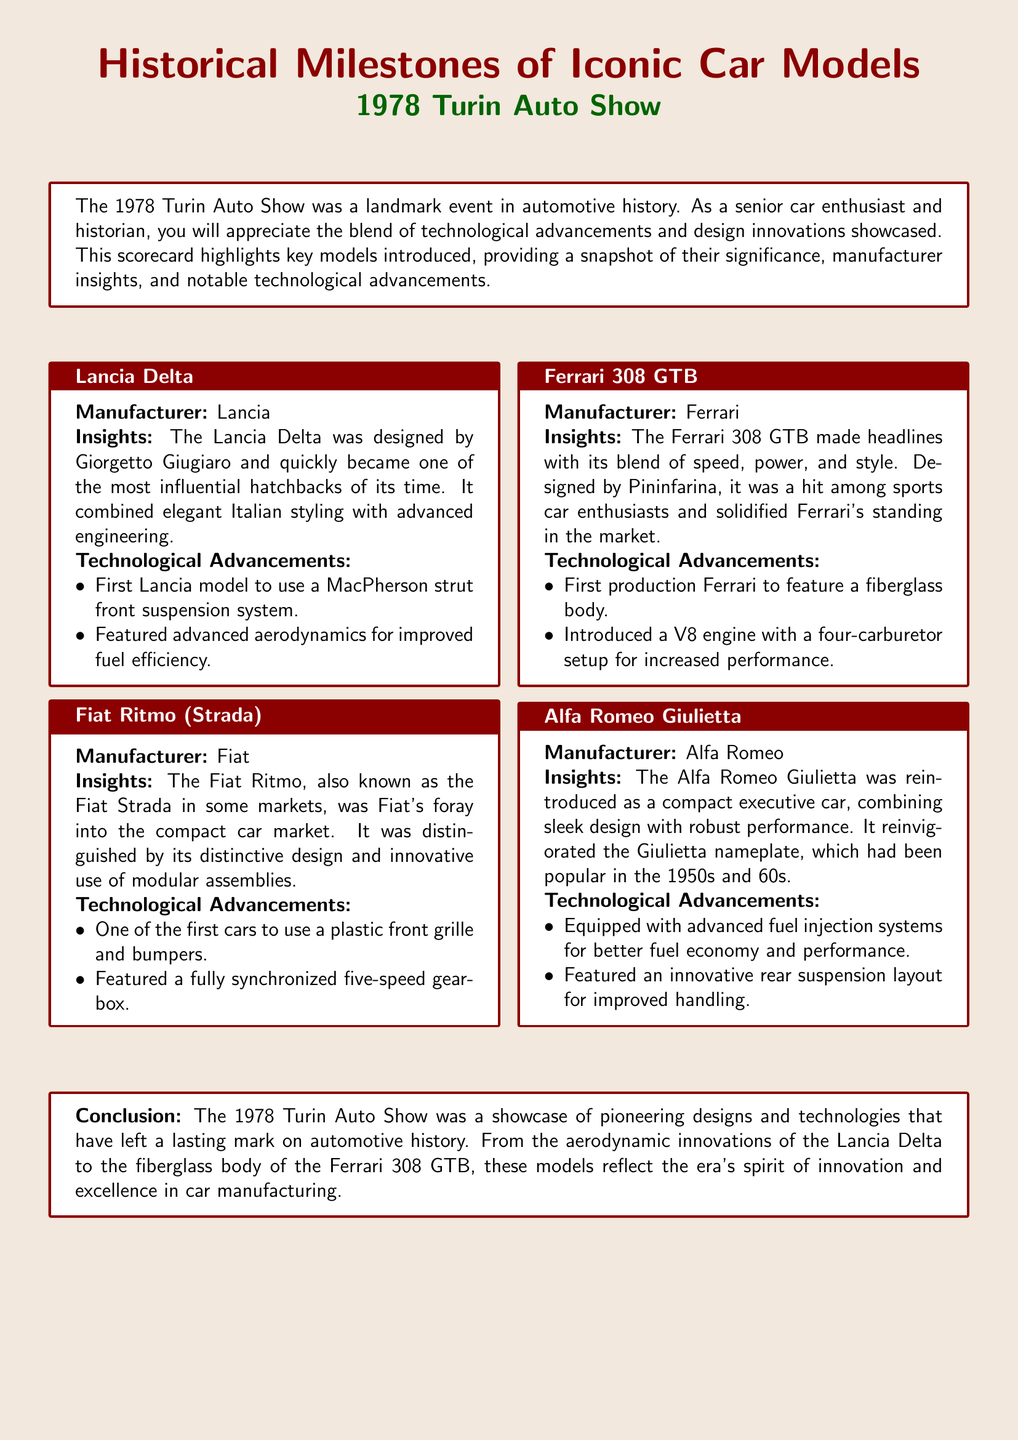What was the first Lancia model to use a MacPherson strut front suspension? According to the document, the Lancia Delta was the first model to feature this suspension system.
Answer: Lancia Delta Who designed the Ferrari 308 GTB? The document states that the Ferrari 308 GTB was designed by Pininfarina.
Answer: Pininfarina What technology did the Alfa Romeo Giulietta integrate for fuel economy? The document mentions that it was equipped with advanced fuel injection systems for better fuel economy.
Answer: Advanced fuel injection systems Which model featured a fully synchronized five-speed gearbox? The Fiat Ritmo is highlighted in the document as having this feature.
Answer: Fiat Ritmo How many notable technological advancements are listed for the Ferrari 308 GTB? The document lists two specific advancements for the Ferrari 308 GTB.
Answer: Two What was the manufacturing significance of the Fiat Ritmo? It was Fiat's foray into the compact car market, which indicated its importance in the document.
Answer: Compact car market What was a unique design feature of the Lancia Delta highlighted? The document notes its advanced aerodynamics as a significant design feature.
Answer: Advanced aerodynamics Which car model was reintroduced at the 1978 Turin Auto Show? The Alfa Romeo Giulietta was reintroduced at this event, according to the document.
Answer: Alfa Romeo Giulietta 